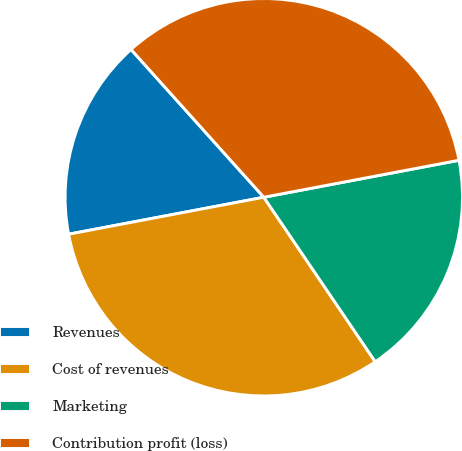<chart> <loc_0><loc_0><loc_500><loc_500><pie_chart><fcel>Revenues<fcel>Cost of revenues<fcel>Marketing<fcel>Contribution profit (loss)<nl><fcel>16.33%<fcel>31.5%<fcel>18.5%<fcel>33.67%<nl></chart> 